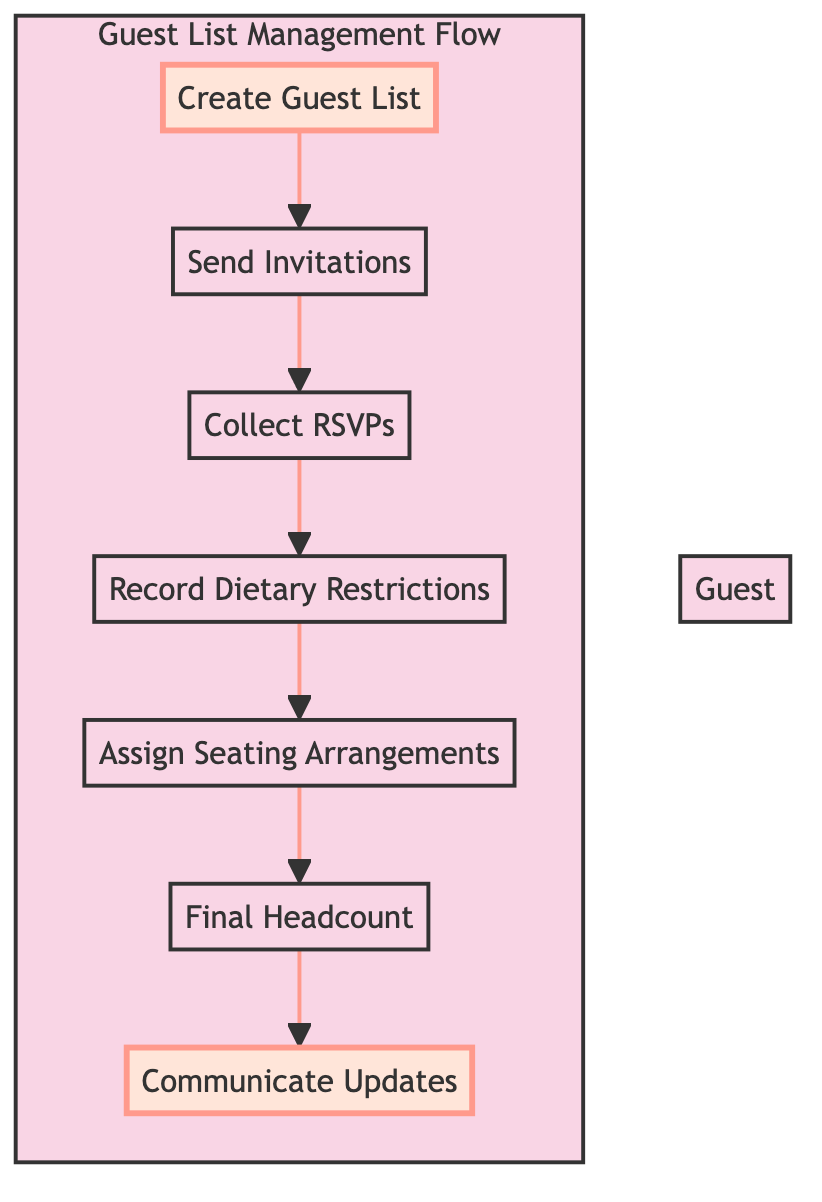What is the first step in the guest list management flow? The diagram shows that the first step is "Create Guest List," as it is the top-most node in the flow.
Answer: Create Guest List How many steps are there in the guest list management flow? By counting the nodes in the flowchart, we see there are seven steps: Create Guest List, Send Invitations, Collect RSVPs, Record Dietary Restrictions, Assign Seating Arrangements, Final Headcount, and Communicate Updates.
Answer: Seven What is the last step in the guest list management flow? The last step, displayed at the bottom of the diagram, is "Communicate Updates," as it is the final node after all other steps.
Answer: Communicate Updates Which step follows the "Collect RSVPs" step? The flowchart indicates that the step following "Collect RSVPs" is "Record Dietary Restrictions," as it is directly connected in the flow downwards.
Answer: Record Dietary Restrictions What is the relationship between "Send Invitations" and "Collect RSVPs"? The diagram shows a direct arrow from "Send Invitations" to "Collect RSVPs," indicating that collecting RSVPs occurs after invitations are sent out.
Answer: Direct connection Which step is highlighted in the diagram? The highlights in the diagram emphasize the "Create Guest List" and "Communicate Updates" steps to visually distinguish them from the others.
Answer: Create Guest List, Communicate Updates What does the "Final Headcount" step depend on? The "Final Headcount" step depends on the previous step "Assign Seating Arrangements" and requires the number of RSVPs collected to confirm attendee count.
Answer: Assign Seating Arrangements, RSVPs What is the purpose of recording dietary restrictions in the flow? The "Record Dietary Restrictions" step is essential for noting any specific dietary needs guests may have, which impacts subsequent catering and seating arrangements.
Answer: Note specific dietary needs How does the flow chart signify the end of the guest list management process? The flowchart ends with the node "Communicate Updates," which indicates the conclusion of the process as it shows a completed flow after guest assignments and updates are communicated.
Answer: Communicate Updates 